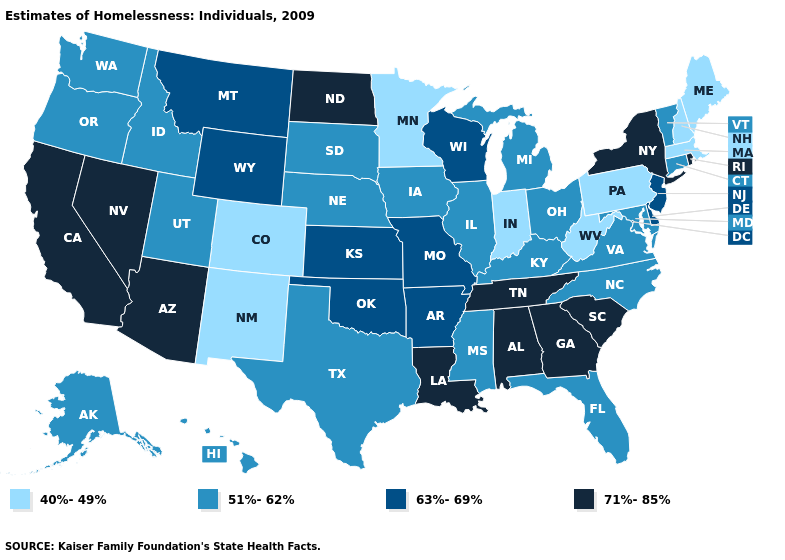Does Illinois have a lower value than Nebraska?
Give a very brief answer. No. Name the states that have a value in the range 40%-49%?
Quick response, please. Colorado, Indiana, Maine, Massachusetts, Minnesota, New Hampshire, New Mexico, Pennsylvania, West Virginia. What is the highest value in the MidWest ?
Quick response, please. 71%-85%. What is the value of New Hampshire?
Short answer required. 40%-49%. What is the value of South Carolina?
Short answer required. 71%-85%. What is the lowest value in the USA?
Be succinct. 40%-49%. What is the value of Nebraska?
Write a very short answer. 51%-62%. Name the states that have a value in the range 51%-62%?
Concise answer only. Alaska, Connecticut, Florida, Hawaii, Idaho, Illinois, Iowa, Kentucky, Maryland, Michigan, Mississippi, Nebraska, North Carolina, Ohio, Oregon, South Dakota, Texas, Utah, Vermont, Virginia, Washington. Name the states that have a value in the range 71%-85%?
Short answer required. Alabama, Arizona, California, Georgia, Louisiana, Nevada, New York, North Dakota, Rhode Island, South Carolina, Tennessee. Name the states that have a value in the range 40%-49%?
Be succinct. Colorado, Indiana, Maine, Massachusetts, Minnesota, New Hampshire, New Mexico, Pennsylvania, West Virginia. Name the states that have a value in the range 51%-62%?
Write a very short answer. Alaska, Connecticut, Florida, Hawaii, Idaho, Illinois, Iowa, Kentucky, Maryland, Michigan, Mississippi, Nebraska, North Carolina, Ohio, Oregon, South Dakota, Texas, Utah, Vermont, Virginia, Washington. What is the value of Missouri?
Be succinct. 63%-69%. What is the value of Nebraska?
Give a very brief answer. 51%-62%. What is the value of Wisconsin?
Quick response, please. 63%-69%. What is the highest value in the USA?
Short answer required. 71%-85%. 